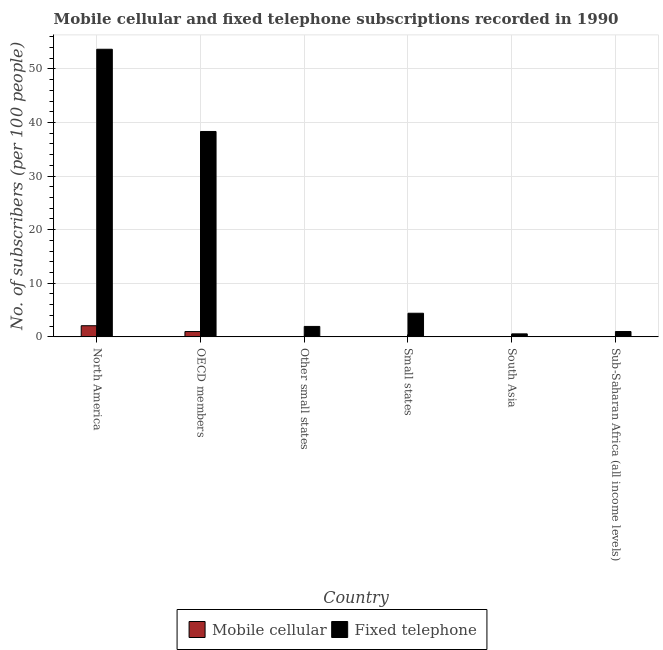Are the number of bars per tick equal to the number of legend labels?
Your response must be concise. Yes. Are the number of bars on each tick of the X-axis equal?
Your answer should be very brief. Yes. How many bars are there on the 2nd tick from the left?
Provide a succinct answer. 2. How many bars are there on the 6th tick from the right?
Offer a very short reply. 2. What is the label of the 3rd group of bars from the left?
Offer a terse response. Other small states. What is the number of fixed telephone subscribers in South Asia?
Provide a succinct answer. 0.56. Across all countries, what is the maximum number of fixed telephone subscribers?
Your response must be concise. 53.66. Across all countries, what is the minimum number of fixed telephone subscribers?
Provide a short and direct response. 0.56. In which country was the number of fixed telephone subscribers minimum?
Your response must be concise. South Asia. What is the total number of fixed telephone subscribers in the graph?
Your answer should be very brief. 99.9. What is the difference between the number of fixed telephone subscribers in North America and that in Sub-Saharan Africa (all income levels)?
Provide a succinct answer. 52.67. What is the difference between the number of fixed telephone subscribers in Sub-Saharan Africa (all income levels) and the number of mobile cellular subscribers in OECD members?
Give a very brief answer. 0.01. What is the average number of fixed telephone subscribers per country?
Keep it short and to the point. 16.65. What is the difference between the number of fixed telephone subscribers and number of mobile cellular subscribers in Small states?
Provide a short and direct response. 4.39. What is the ratio of the number of mobile cellular subscribers in OECD members to that in Sub-Saharan Africa (all income levels)?
Provide a succinct answer. 640.53. Is the difference between the number of mobile cellular subscribers in North America and OECD members greater than the difference between the number of fixed telephone subscribers in North America and OECD members?
Your response must be concise. No. What is the difference between the highest and the second highest number of mobile cellular subscribers?
Offer a very short reply. 1.09. What is the difference between the highest and the lowest number of fixed telephone subscribers?
Keep it short and to the point. 53.1. In how many countries, is the number of fixed telephone subscribers greater than the average number of fixed telephone subscribers taken over all countries?
Make the answer very short. 2. Is the sum of the number of mobile cellular subscribers in Small states and Sub-Saharan Africa (all income levels) greater than the maximum number of fixed telephone subscribers across all countries?
Ensure brevity in your answer.  No. What does the 2nd bar from the left in North America represents?
Your answer should be very brief. Fixed telephone. What does the 2nd bar from the right in South Asia represents?
Ensure brevity in your answer.  Mobile cellular. How many bars are there?
Your answer should be very brief. 12. What is the difference between two consecutive major ticks on the Y-axis?
Provide a succinct answer. 10. Are the values on the major ticks of Y-axis written in scientific E-notation?
Ensure brevity in your answer.  No. Where does the legend appear in the graph?
Your answer should be compact. Bottom center. How many legend labels are there?
Make the answer very short. 2. What is the title of the graph?
Provide a succinct answer. Mobile cellular and fixed telephone subscriptions recorded in 1990. Does "Domestic Liabilities" appear as one of the legend labels in the graph?
Offer a terse response. No. What is the label or title of the X-axis?
Provide a succinct answer. Country. What is the label or title of the Y-axis?
Offer a very short reply. No. of subscribers (per 100 people). What is the No. of subscribers (per 100 people) in Mobile cellular in North America?
Keep it short and to the point. 2.08. What is the No. of subscribers (per 100 people) of Fixed telephone in North America?
Make the answer very short. 53.66. What is the No. of subscribers (per 100 people) in Mobile cellular in OECD members?
Ensure brevity in your answer.  0.99. What is the No. of subscribers (per 100 people) in Fixed telephone in OECD members?
Offer a terse response. 38.32. What is the No. of subscribers (per 100 people) in Mobile cellular in Other small states?
Make the answer very short. 0.02. What is the No. of subscribers (per 100 people) in Fixed telephone in Other small states?
Your answer should be compact. 1.95. What is the No. of subscribers (per 100 people) in Mobile cellular in Small states?
Offer a terse response. 0.02. What is the No. of subscribers (per 100 people) in Fixed telephone in Small states?
Provide a succinct answer. 4.41. What is the No. of subscribers (per 100 people) of Mobile cellular in South Asia?
Offer a terse response. 0. What is the No. of subscribers (per 100 people) of Fixed telephone in South Asia?
Ensure brevity in your answer.  0.56. What is the No. of subscribers (per 100 people) of Mobile cellular in Sub-Saharan Africa (all income levels)?
Provide a succinct answer. 0. What is the No. of subscribers (per 100 people) in Fixed telephone in Sub-Saharan Africa (all income levels)?
Offer a very short reply. 1. Across all countries, what is the maximum No. of subscribers (per 100 people) in Mobile cellular?
Provide a succinct answer. 2.08. Across all countries, what is the maximum No. of subscribers (per 100 people) of Fixed telephone?
Keep it short and to the point. 53.66. Across all countries, what is the minimum No. of subscribers (per 100 people) in Mobile cellular?
Provide a short and direct response. 0. Across all countries, what is the minimum No. of subscribers (per 100 people) of Fixed telephone?
Offer a terse response. 0.56. What is the total No. of subscribers (per 100 people) in Mobile cellular in the graph?
Give a very brief answer. 3.11. What is the total No. of subscribers (per 100 people) of Fixed telephone in the graph?
Your answer should be compact. 99.9. What is the difference between the No. of subscribers (per 100 people) of Mobile cellular in North America and that in OECD members?
Your response must be concise. 1.09. What is the difference between the No. of subscribers (per 100 people) in Fixed telephone in North America and that in OECD members?
Give a very brief answer. 15.34. What is the difference between the No. of subscribers (per 100 people) in Mobile cellular in North America and that in Other small states?
Your answer should be compact. 2.06. What is the difference between the No. of subscribers (per 100 people) of Fixed telephone in North America and that in Other small states?
Provide a succinct answer. 51.71. What is the difference between the No. of subscribers (per 100 people) in Mobile cellular in North America and that in Small states?
Your answer should be compact. 2.06. What is the difference between the No. of subscribers (per 100 people) of Fixed telephone in North America and that in Small states?
Keep it short and to the point. 49.25. What is the difference between the No. of subscribers (per 100 people) in Mobile cellular in North America and that in South Asia?
Offer a terse response. 2.08. What is the difference between the No. of subscribers (per 100 people) in Fixed telephone in North America and that in South Asia?
Give a very brief answer. 53.1. What is the difference between the No. of subscribers (per 100 people) of Mobile cellular in North America and that in Sub-Saharan Africa (all income levels)?
Offer a very short reply. 2.08. What is the difference between the No. of subscribers (per 100 people) in Fixed telephone in North America and that in Sub-Saharan Africa (all income levels)?
Make the answer very short. 52.67. What is the difference between the No. of subscribers (per 100 people) of Mobile cellular in OECD members and that in Other small states?
Your answer should be compact. 0.97. What is the difference between the No. of subscribers (per 100 people) in Fixed telephone in OECD members and that in Other small states?
Your answer should be compact. 36.37. What is the difference between the No. of subscribers (per 100 people) in Mobile cellular in OECD members and that in Small states?
Your response must be concise. 0.97. What is the difference between the No. of subscribers (per 100 people) of Fixed telephone in OECD members and that in Small states?
Offer a very short reply. 33.91. What is the difference between the No. of subscribers (per 100 people) of Mobile cellular in OECD members and that in South Asia?
Your answer should be compact. 0.99. What is the difference between the No. of subscribers (per 100 people) of Fixed telephone in OECD members and that in South Asia?
Provide a short and direct response. 37.76. What is the difference between the No. of subscribers (per 100 people) of Fixed telephone in OECD members and that in Sub-Saharan Africa (all income levels)?
Provide a succinct answer. 37.32. What is the difference between the No. of subscribers (per 100 people) in Mobile cellular in Other small states and that in Small states?
Provide a short and direct response. -0. What is the difference between the No. of subscribers (per 100 people) of Fixed telephone in Other small states and that in Small states?
Your answer should be very brief. -2.46. What is the difference between the No. of subscribers (per 100 people) in Mobile cellular in Other small states and that in South Asia?
Provide a succinct answer. 0.02. What is the difference between the No. of subscribers (per 100 people) in Fixed telephone in Other small states and that in South Asia?
Ensure brevity in your answer.  1.39. What is the difference between the No. of subscribers (per 100 people) in Mobile cellular in Other small states and that in Sub-Saharan Africa (all income levels)?
Make the answer very short. 0.02. What is the difference between the No. of subscribers (per 100 people) of Fixed telephone in Other small states and that in Sub-Saharan Africa (all income levels)?
Provide a short and direct response. 0.95. What is the difference between the No. of subscribers (per 100 people) of Mobile cellular in Small states and that in South Asia?
Ensure brevity in your answer.  0.02. What is the difference between the No. of subscribers (per 100 people) in Fixed telephone in Small states and that in South Asia?
Ensure brevity in your answer.  3.85. What is the difference between the No. of subscribers (per 100 people) of Mobile cellular in Small states and that in Sub-Saharan Africa (all income levels)?
Provide a succinct answer. 0.02. What is the difference between the No. of subscribers (per 100 people) in Fixed telephone in Small states and that in Sub-Saharan Africa (all income levels)?
Make the answer very short. 3.41. What is the difference between the No. of subscribers (per 100 people) of Mobile cellular in South Asia and that in Sub-Saharan Africa (all income levels)?
Give a very brief answer. -0. What is the difference between the No. of subscribers (per 100 people) of Fixed telephone in South Asia and that in Sub-Saharan Africa (all income levels)?
Your answer should be very brief. -0.44. What is the difference between the No. of subscribers (per 100 people) of Mobile cellular in North America and the No. of subscribers (per 100 people) of Fixed telephone in OECD members?
Provide a succinct answer. -36.24. What is the difference between the No. of subscribers (per 100 people) in Mobile cellular in North America and the No. of subscribers (per 100 people) in Fixed telephone in Other small states?
Provide a succinct answer. 0.13. What is the difference between the No. of subscribers (per 100 people) in Mobile cellular in North America and the No. of subscribers (per 100 people) in Fixed telephone in Small states?
Your answer should be compact. -2.33. What is the difference between the No. of subscribers (per 100 people) in Mobile cellular in North America and the No. of subscribers (per 100 people) in Fixed telephone in South Asia?
Provide a short and direct response. 1.52. What is the difference between the No. of subscribers (per 100 people) in Mobile cellular in North America and the No. of subscribers (per 100 people) in Fixed telephone in Sub-Saharan Africa (all income levels)?
Your response must be concise. 1.08. What is the difference between the No. of subscribers (per 100 people) of Mobile cellular in OECD members and the No. of subscribers (per 100 people) of Fixed telephone in Other small states?
Your answer should be very brief. -0.96. What is the difference between the No. of subscribers (per 100 people) in Mobile cellular in OECD members and the No. of subscribers (per 100 people) in Fixed telephone in Small states?
Ensure brevity in your answer.  -3.42. What is the difference between the No. of subscribers (per 100 people) in Mobile cellular in OECD members and the No. of subscribers (per 100 people) in Fixed telephone in South Asia?
Provide a short and direct response. 0.43. What is the difference between the No. of subscribers (per 100 people) in Mobile cellular in OECD members and the No. of subscribers (per 100 people) in Fixed telephone in Sub-Saharan Africa (all income levels)?
Offer a very short reply. -0.01. What is the difference between the No. of subscribers (per 100 people) of Mobile cellular in Other small states and the No. of subscribers (per 100 people) of Fixed telephone in Small states?
Offer a very short reply. -4.39. What is the difference between the No. of subscribers (per 100 people) of Mobile cellular in Other small states and the No. of subscribers (per 100 people) of Fixed telephone in South Asia?
Provide a succinct answer. -0.54. What is the difference between the No. of subscribers (per 100 people) in Mobile cellular in Other small states and the No. of subscribers (per 100 people) in Fixed telephone in Sub-Saharan Africa (all income levels)?
Your response must be concise. -0.98. What is the difference between the No. of subscribers (per 100 people) of Mobile cellular in Small states and the No. of subscribers (per 100 people) of Fixed telephone in South Asia?
Your answer should be very brief. -0.54. What is the difference between the No. of subscribers (per 100 people) in Mobile cellular in Small states and the No. of subscribers (per 100 people) in Fixed telephone in Sub-Saharan Africa (all income levels)?
Make the answer very short. -0.98. What is the difference between the No. of subscribers (per 100 people) in Mobile cellular in South Asia and the No. of subscribers (per 100 people) in Fixed telephone in Sub-Saharan Africa (all income levels)?
Offer a very short reply. -1. What is the average No. of subscribers (per 100 people) of Mobile cellular per country?
Your answer should be very brief. 0.52. What is the average No. of subscribers (per 100 people) in Fixed telephone per country?
Provide a short and direct response. 16.65. What is the difference between the No. of subscribers (per 100 people) in Mobile cellular and No. of subscribers (per 100 people) in Fixed telephone in North America?
Give a very brief answer. -51.58. What is the difference between the No. of subscribers (per 100 people) in Mobile cellular and No. of subscribers (per 100 people) in Fixed telephone in OECD members?
Ensure brevity in your answer.  -37.33. What is the difference between the No. of subscribers (per 100 people) in Mobile cellular and No. of subscribers (per 100 people) in Fixed telephone in Other small states?
Ensure brevity in your answer.  -1.93. What is the difference between the No. of subscribers (per 100 people) in Mobile cellular and No. of subscribers (per 100 people) in Fixed telephone in Small states?
Ensure brevity in your answer.  -4.39. What is the difference between the No. of subscribers (per 100 people) in Mobile cellular and No. of subscribers (per 100 people) in Fixed telephone in South Asia?
Offer a terse response. -0.56. What is the difference between the No. of subscribers (per 100 people) of Mobile cellular and No. of subscribers (per 100 people) of Fixed telephone in Sub-Saharan Africa (all income levels)?
Give a very brief answer. -0.99. What is the ratio of the No. of subscribers (per 100 people) in Mobile cellular in North America to that in OECD members?
Offer a very short reply. 2.1. What is the ratio of the No. of subscribers (per 100 people) in Fixed telephone in North America to that in OECD members?
Provide a short and direct response. 1.4. What is the ratio of the No. of subscribers (per 100 people) of Mobile cellular in North America to that in Other small states?
Your response must be concise. 119.22. What is the ratio of the No. of subscribers (per 100 people) in Fixed telephone in North America to that in Other small states?
Your response must be concise. 27.53. What is the ratio of the No. of subscribers (per 100 people) in Mobile cellular in North America to that in Small states?
Your response must be concise. 98.42. What is the ratio of the No. of subscribers (per 100 people) in Fixed telephone in North America to that in Small states?
Keep it short and to the point. 12.17. What is the ratio of the No. of subscribers (per 100 people) of Mobile cellular in North America to that in South Asia?
Provide a succinct answer. 7842.05. What is the ratio of the No. of subscribers (per 100 people) of Fixed telephone in North America to that in South Asia?
Your answer should be compact. 95.8. What is the ratio of the No. of subscribers (per 100 people) in Mobile cellular in North America to that in Sub-Saharan Africa (all income levels)?
Give a very brief answer. 1344.46. What is the ratio of the No. of subscribers (per 100 people) in Fixed telephone in North America to that in Sub-Saharan Africa (all income levels)?
Offer a terse response. 53.85. What is the ratio of the No. of subscribers (per 100 people) of Mobile cellular in OECD members to that in Other small states?
Provide a succinct answer. 56.8. What is the ratio of the No. of subscribers (per 100 people) of Fixed telephone in OECD members to that in Other small states?
Keep it short and to the point. 19.66. What is the ratio of the No. of subscribers (per 100 people) of Mobile cellular in OECD members to that in Small states?
Provide a short and direct response. 46.89. What is the ratio of the No. of subscribers (per 100 people) of Fixed telephone in OECD members to that in Small states?
Offer a very short reply. 8.69. What is the ratio of the No. of subscribers (per 100 people) of Mobile cellular in OECD members to that in South Asia?
Your answer should be very brief. 3736.13. What is the ratio of the No. of subscribers (per 100 people) in Fixed telephone in OECD members to that in South Asia?
Keep it short and to the point. 68.41. What is the ratio of the No. of subscribers (per 100 people) in Mobile cellular in OECD members to that in Sub-Saharan Africa (all income levels)?
Your answer should be compact. 640.53. What is the ratio of the No. of subscribers (per 100 people) in Fixed telephone in OECD members to that in Sub-Saharan Africa (all income levels)?
Keep it short and to the point. 38.46. What is the ratio of the No. of subscribers (per 100 people) in Mobile cellular in Other small states to that in Small states?
Keep it short and to the point. 0.83. What is the ratio of the No. of subscribers (per 100 people) of Fixed telephone in Other small states to that in Small states?
Offer a very short reply. 0.44. What is the ratio of the No. of subscribers (per 100 people) in Mobile cellular in Other small states to that in South Asia?
Offer a terse response. 65.78. What is the ratio of the No. of subscribers (per 100 people) in Fixed telephone in Other small states to that in South Asia?
Give a very brief answer. 3.48. What is the ratio of the No. of subscribers (per 100 people) in Mobile cellular in Other small states to that in Sub-Saharan Africa (all income levels)?
Your answer should be very brief. 11.28. What is the ratio of the No. of subscribers (per 100 people) of Fixed telephone in Other small states to that in Sub-Saharan Africa (all income levels)?
Your response must be concise. 1.96. What is the ratio of the No. of subscribers (per 100 people) in Mobile cellular in Small states to that in South Asia?
Offer a terse response. 79.68. What is the ratio of the No. of subscribers (per 100 people) in Fixed telephone in Small states to that in South Asia?
Your response must be concise. 7.87. What is the ratio of the No. of subscribers (per 100 people) in Mobile cellular in Small states to that in Sub-Saharan Africa (all income levels)?
Give a very brief answer. 13.66. What is the ratio of the No. of subscribers (per 100 people) of Fixed telephone in Small states to that in Sub-Saharan Africa (all income levels)?
Your answer should be compact. 4.43. What is the ratio of the No. of subscribers (per 100 people) in Mobile cellular in South Asia to that in Sub-Saharan Africa (all income levels)?
Provide a succinct answer. 0.17. What is the ratio of the No. of subscribers (per 100 people) in Fixed telephone in South Asia to that in Sub-Saharan Africa (all income levels)?
Offer a very short reply. 0.56. What is the difference between the highest and the second highest No. of subscribers (per 100 people) of Mobile cellular?
Your answer should be compact. 1.09. What is the difference between the highest and the second highest No. of subscribers (per 100 people) of Fixed telephone?
Offer a terse response. 15.34. What is the difference between the highest and the lowest No. of subscribers (per 100 people) of Mobile cellular?
Keep it short and to the point. 2.08. What is the difference between the highest and the lowest No. of subscribers (per 100 people) in Fixed telephone?
Your answer should be compact. 53.1. 